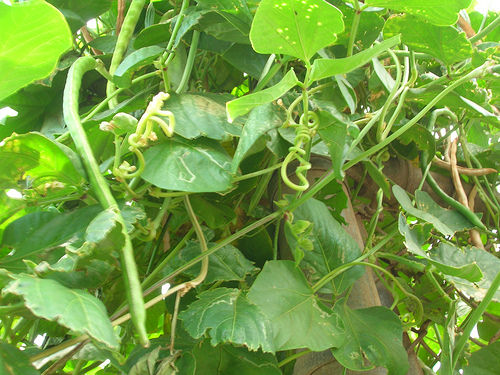<image>
Can you confirm if the leaf is behind the bean? Yes. From this viewpoint, the leaf is positioned behind the bean, with the bean partially or fully occluding the leaf. Where is the bean in relation to the leaf? Is it in front of the leaf? No. The bean is not in front of the leaf. The spatial positioning shows a different relationship between these objects. 